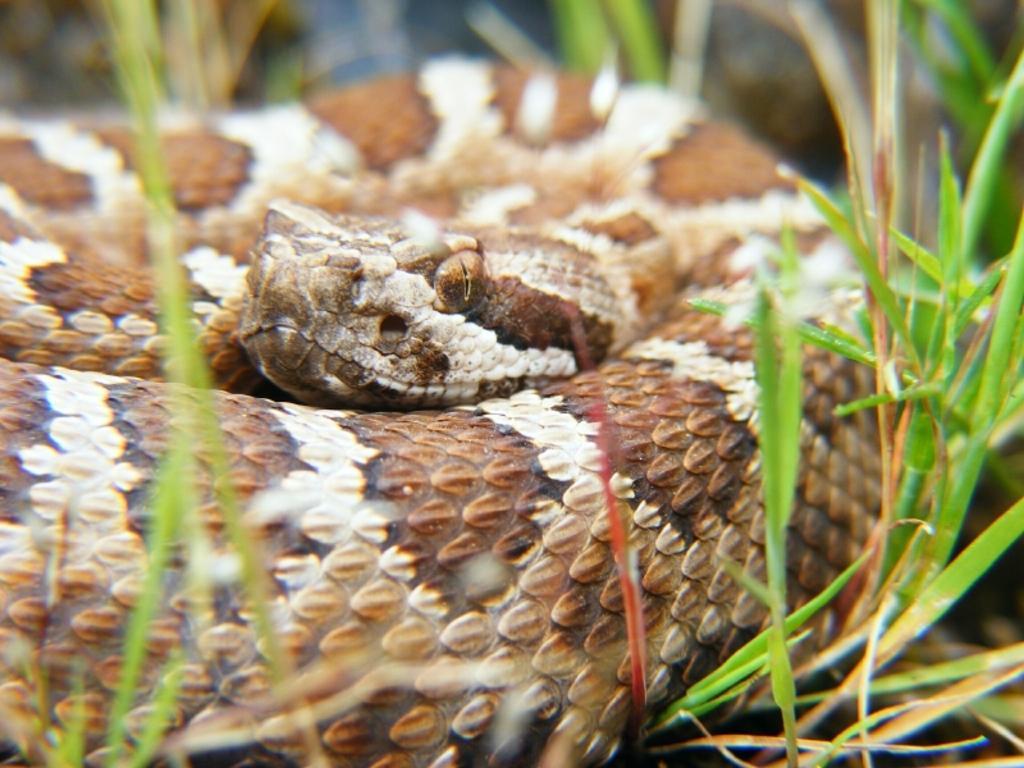How would you summarize this image in a sentence or two? In this image there is a snake on the ground. Beside it there is the grass. 